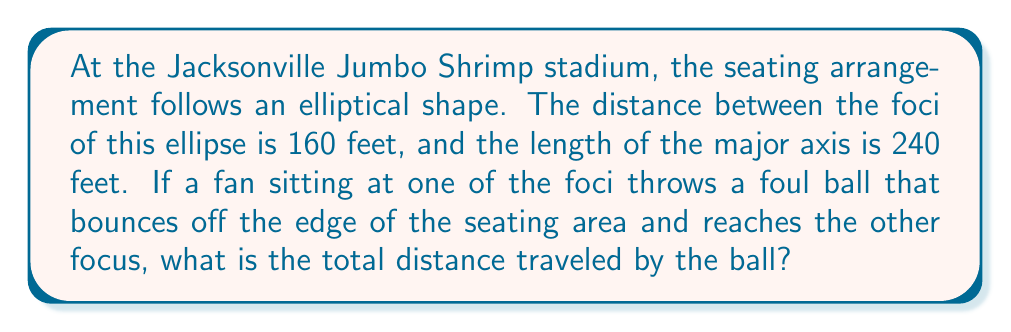What is the answer to this math problem? Let's approach this step-by-step:

1) First, recall the definition of an ellipse: the sum of the distances from any point on the ellipse to the two foci is constant and equal to the length of the major axis.

2) In this case, the length of the major axis is 240 feet. Let's call this $2a$, so $a = 120$ feet.

3) The distance between the foci is 160 feet. This is typically denoted as $2c$. So $c = 80$ feet.

4) We can find the length of the minor axis ($2b$) using the Pythagorean theorem:

   $$a^2 = b^2 + c^2$$
   $$120^2 = b^2 + 80^2$$
   $$14400 = b^2 + 6400$$
   $$b^2 = 8000$$
   $$b = \sqrt{8000} \approx 89.44$$

5) However, we don't actually need $b$ for this problem.

6) The ball starts at one focus, bounces off the ellipse, and reaches the other focus. By the definition of an ellipse, this total distance will always be equal to the major axis, regardless of where on the ellipse the ball bounces.

7) Therefore, the total distance traveled by the ball is equal to the length of the major axis, which is 240 feet.
Answer: 240 feet 